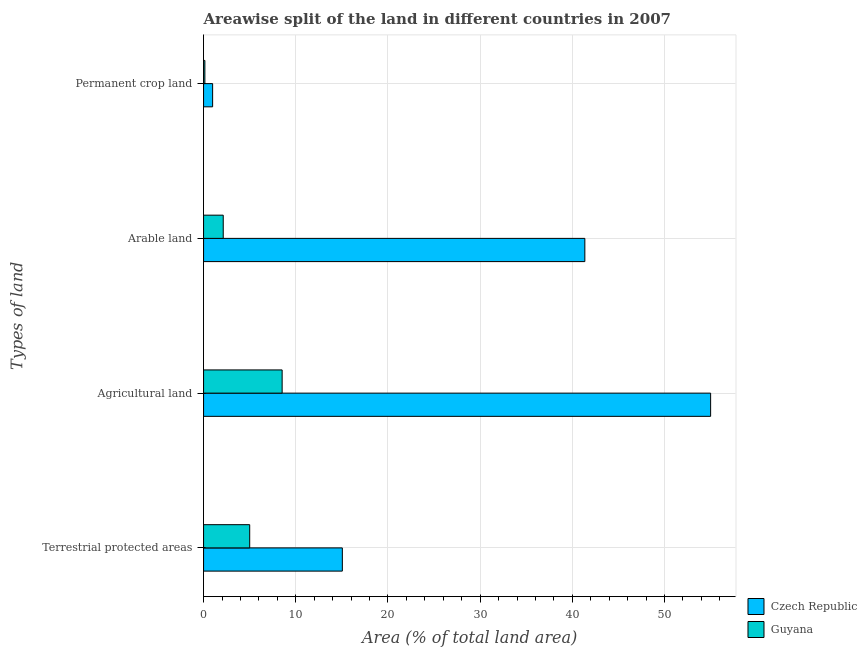How many different coloured bars are there?
Your answer should be very brief. 2. Are the number of bars per tick equal to the number of legend labels?
Your answer should be compact. Yes. How many bars are there on the 4th tick from the top?
Offer a very short reply. 2. What is the label of the 1st group of bars from the top?
Your answer should be very brief. Permanent crop land. What is the percentage of area under arable land in Guyana?
Provide a short and direct response. 2.13. Across all countries, what is the maximum percentage of area under arable land?
Ensure brevity in your answer.  41.36. Across all countries, what is the minimum percentage of area under arable land?
Offer a terse response. 2.13. In which country was the percentage of area under permanent crop land maximum?
Keep it short and to the point. Czech Republic. In which country was the percentage of land under terrestrial protection minimum?
Give a very brief answer. Guyana. What is the total percentage of area under agricultural land in the graph?
Ensure brevity in your answer.  63.53. What is the difference between the percentage of land under terrestrial protection in Czech Republic and that in Guyana?
Offer a very short reply. 10.05. What is the difference between the percentage of land under terrestrial protection in Guyana and the percentage of area under arable land in Czech Republic?
Your answer should be compact. -36.35. What is the average percentage of area under agricultural land per country?
Keep it short and to the point. 31.76. What is the difference between the percentage of area under agricultural land and percentage of area under permanent crop land in Czech Republic?
Give a very brief answer. 54.02. In how many countries, is the percentage of land under terrestrial protection greater than 50 %?
Offer a terse response. 0. What is the ratio of the percentage of land under terrestrial protection in Czech Republic to that in Guyana?
Your answer should be compact. 3.01. Is the percentage of area under agricultural land in Czech Republic less than that in Guyana?
Provide a succinct answer. No. Is the difference between the percentage of area under agricultural land in Czech Republic and Guyana greater than the difference between the percentage of area under permanent crop land in Czech Republic and Guyana?
Your response must be concise. Yes. What is the difference between the highest and the second highest percentage of land under terrestrial protection?
Offer a terse response. 10.05. What is the difference between the highest and the lowest percentage of area under arable land?
Make the answer very short. 39.23. What does the 2nd bar from the top in Agricultural land represents?
Your answer should be compact. Czech Republic. What does the 2nd bar from the bottom in Terrestrial protected areas represents?
Keep it short and to the point. Guyana. How many bars are there?
Your response must be concise. 8. How many countries are there in the graph?
Make the answer very short. 2. What is the difference between two consecutive major ticks on the X-axis?
Your answer should be very brief. 10. Does the graph contain any zero values?
Your answer should be compact. No. How many legend labels are there?
Provide a short and direct response. 2. How are the legend labels stacked?
Offer a terse response. Vertical. What is the title of the graph?
Offer a very short reply. Areawise split of the land in different countries in 2007. What is the label or title of the X-axis?
Offer a terse response. Area (% of total land area). What is the label or title of the Y-axis?
Provide a short and direct response. Types of land. What is the Area (% of total land area) in Czech Republic in Terrestrial protected areas?
Your answer should be very brief. 15.05. What is the Area (% of total land area) in Guyana in Terrestrial protected areas?
Your answer should be compact. 5. What is the Area (% of total land area) of Czech Republic in Agricultural land?
Provide a succinct answer. 55. What is the Area (% of total land area) of Guyana in Agricultural land?
Your answer should be very brief. 8.52. What is the Area (% of total land area) in Czech Republic in Arable land?
Provide a succinct answer. 41.36. What is the Area (% of total land area) in Guyana in Arable land?
Your answer should be compact. 2.13. What is the Area (% of total land area) of Czech Republic in Permanent crop land?
Provide a succinct answer. 0.98. What is the Area (% of total land area) in Guyana in Permanent crop land?
Your answer should be compact. 0.14. Across all Types of land, what is the maximum Area (% of total land area) in Czech Republic?
Ensure brevity in your answer.  55. Across all Types of land, what is the maximum Area (% of total land area) in Guyana?
Offer a terse response. 8.52. Across all Types of land, what is the minimum Area (% of total land area) of Czech Republic?
Provide a succinct answer. 0.98. Across all Types of land, what is the minimum Area (% of total land area) in Guyana?
Offer a very short reply. 0.14. What is the total Area (% of total land area) of Czech Republic in the graph?
Make the answer very short. 112.4. What is the total Area (% of total land area) of Guyana in the graph?
Ensure brevity in your answer.  15.8. What is the difference between the Area (% of total land area) of Czech Republic in Terrestrial protected areas and that in Agricultural land?
Give a very brief answer. -39.95. What is the difference between the Area (% of total land area) in Guyana in Terrestrial protected areas and that in Agricultural land?
Your answer should be very brief. -3.52. What is the difference between the Area (% of total land area) of Czech Republic in Terrestrial protected areas and that in Arable land?
Offer a very short reply. -26.3. What is the difference between the Area (% of total land area) in Guyana in Terrestrial protected areas and that in Arable land?
Your answer should be very brief. 2.87. What is the difference between the Area (% of total land area) in Czech Republic in Terrestrial protected areas and that in Permanent crop land?
Your response must be concise. 14.07. What is the difference between the Area (% of total land area) in Guyana in Terrestrial protected areas and that in Permanent crop land?
Keep it short and to the point. 4.86. What is the difference between the Area (% of total land area) of Czech Republic in Agricultural land and that in Arable land?
Ensure brevity in your answer.  13.64. What is the difference between the Area (% of total land area) of Guyana in Agricultural land and that in Arable land?
Provide a short and direct response. 6.39. What is the difference between the Area (% of total land area) in Czech Republic in Agricultural land and that in Permanent crop land?
Make the answer very short. 54.02. What is the difference between the Area (% of total land area) of Guyana in Agricultural land and that in Permanent crop land?
Your response must be concise. 8.38. What is the difference between the Area (% of total land area) in Czech Republic in Arable land and that in Permanent crop land?
Your response must be concise. 40.38. What is the difference between the Area (% of total land area) in Guyana in Arable land and that in Permanent crop land?
Offer a terse response. 1.99. What is the difference between the Area (% of total land area) of Czech Republic in Terrestrial protected areas and the Area (% of total land area) of Guyana in Agricultural land?
Offer a very short reply. 6.53. What is the difference between the Area (% of total land area) in Czech Republic in Terrestrial protected areas and the Area (% of total land area) in Guyana in Arable land?
Offer a very short reply. 12.92. What is the difference between the Area (% of total land area) of Czech Republic in Terrestrial protected areas and the Area (% of total land area) of Guyana in Permanent crop land?
Your response must be concise. 14.91. What is the difference between the Area (% of total land area) of Czech Republic in Agricultural land and the Area (% of total land area) of Guyana in Arable land?
Make the answer very short. 52.87. What is the difference between the Area (% of total land area) of Czech Republic in Agricultural land and the Area (% of total land area) of Guyana in Permanent crop land?
Keep it short and to the point. 54.86. What is the difference between the Area (% of total land area) of Czech Republic in Arable land and the Area (% of total land area) of Guyana in Permanent crop land?
Your answer should be compact. 41.22. What is the average Area (% of total land area) of Czech Republic per Types of land?
Provide a short and direct response. 28.1. What is the average Area (% of total land area) of Guyana per Types of land?
Keep it short and to the point. 3.95. What is the difference between the Area (% of total land area) of Czech Republic and Area (% of total land area) of Guyana in Terrestrial protected areas?
Your answer should be compact. 10.05. What is the difference between the Area (% of total land area) in Czech Republic and Area (% of total land area) in Guyana in Agricultural land?
Keep it short and to the point. 46.48. What is the difference between the Area (% of total land area) of Czech Republic and Area (% of total land area) of Guyana in Arable land?
Offer a very short reply. 39.23. What is the difference between the Area (% of total land area) in Czech Republic and Area (% of total land area) in Guyana in Permanent crop land?
Make the answer very short. 0.84. What is the ratio of the Area (% of total land area) of Czech Republic in Terrestrial protected areas to that in Agricultural land?
Your response must be concise. 0.27. What is the ratio of the Area (% of total land area) of Guyana in Terrestrial protected areas to that in Agricultural land?
Your answer should be very brief. 0.59. What is the ratio of the Area (% of total land area) of Czech Republic in Terrestrial protected areas to that in Arable land?
Your answer should be very brief. 0.36. What is the ratio of the Area (% of total land area) in Guyana in Terrestrial protected areas to that in Arable land?
Provide a succinct answer. 2.35. What is the ratio of the Area (% of total land area) of Czech Republic in Terrestrial protected areas to that in Permanent crop land?
Make the answer very short. 15.3. What is the ratio of the Area (% of total land area) of Guyana in Terrestrial protected areas to that in Permanent crop land?
Provide a succinct answer. 35.18. What is the ratio of the Area (% of total land area) of Czech Republic in Agricultural land to that in Arable land?
Your answer should be compact. 1.33. What is the ratio of the Area (% of total land area) in Guyana in Agricultural land to that in Arable land?
Provide a succinct answer. 4. What is the ratio of the Area (% of total land area) of Czech Republic in Agricultural land to that in Permanent crop land?
Provide a short and direct response. 55.91. What is the ratio of the Area (% of total land area) of Guyana in Agricultural land to that in Permanent crop land?
Ensure brevity in your answer.  59.93. What is the ratio of the Area (% of total land area) in Czech Republic in Arable land to that in Permanent crop land?
Keep it short and to the point. 42.04. What is the ratio of the Area (% of total land area) in Guyana in Arable land to that in Permanent crop land?
Make the answer very short. 15. What is the difference between the highest and the second highest Area (% of total land area) in Czech Republic?
Your response must be concise. 13.64. What is the difference between the highest and the second highest Area (% of total land area) of Guyana?
Give a very brief answer. 3.52. What is the difference between the highest and the lowest Area (% of total land area) in Czech Republic?
Keep it short and to the point. 54.02. What is the difference between the highest and the lowest Area (% of total land area) of Guyana?
Keep it short and to the point. 8.38. 